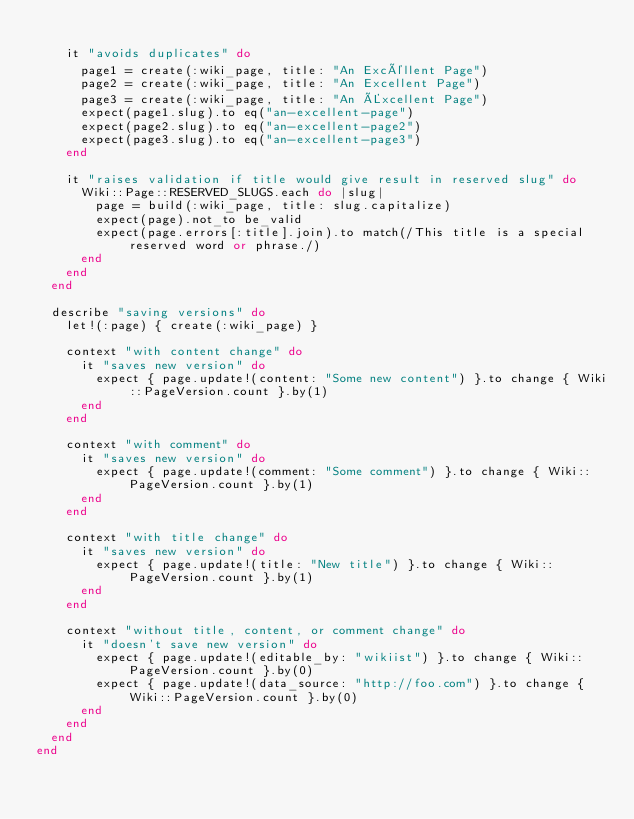Convert code to text. <code><loc_0><loc_0><loc_500><loc_500><_Ruby_>
    it "avoids duplicates" do
      page1 = create(:wiki_page, title: "An Excéllent Page")
      page2 = create(:wiki_page, title: "An Excellent Page")
      page3 = create(:wiki_page, title: "An Éxcellent Page")
      expect(page1.slug).to eq("an-excellent-page")
      expect(page2.slug).to eq("an-excellent-page2")
      expect(page3.slug).to eq("an-excellent-page3")
    end

    it "raises validation if title would give result in reserved slug" do
      Wiki::Page::RESERVED_SLUGS.each do |slug|
        page = build(:wiki_page, title: slug.capitalize)
        expect(page).not_to be_valid
        expect(page.errors[:title].join).to match(/This title is a special reserved word or phrase./)
      end
    end
  end

  describe "saving versions" do
    let!(:page) { create(:wiki_page) }

    context "with content change" do
      it "saves new version" do
        expect { page.update!(content: "Some new content") }.to change { Wiki::PageVersion.count }.by(1)
      end
    end

    context "with comment" do
      it "saves new version" do
        expect { page.update!(comment: "Some comment") }.to change { Wiki::PageVersion.count }.by(1)
      end
    end

    context "with title change" do
      it "saves new version" do
        expect { page.update!(title: "New title") }.to change { Wiki::PageVersion.count }.by(1)
      end
    end

    context "without title, content, or comment change" do
      it "doesn't save new version" do
        expect { page.update!(editable_by: "wikiist") }.to change { Wiki::PageVersion.count }.by(0)
        expect { page.update!(data_source: "http://foo.com") }.to change { Wiki::PageVersion.count }.by(0)
      end
    end
  end
end
</code> 